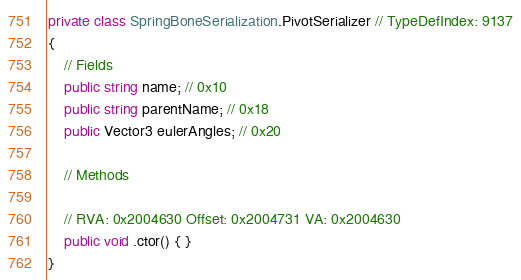<code> <loc_0><loc_0><loc_500><loc_500><_C#_>private class SpringBoneSerialization.PivotSerializer // TypeDefIndex: 9137
{
	// Fields
	public string name; // 0x10
	public string parentName; // 0x18
	public Vector3 eulerAngles; // 0x20

	// Methods

	// RVA: 0x2004630 Offset: 0x2004731 VA: 0x2004630
	public void .ctor() { }
}

</code> 